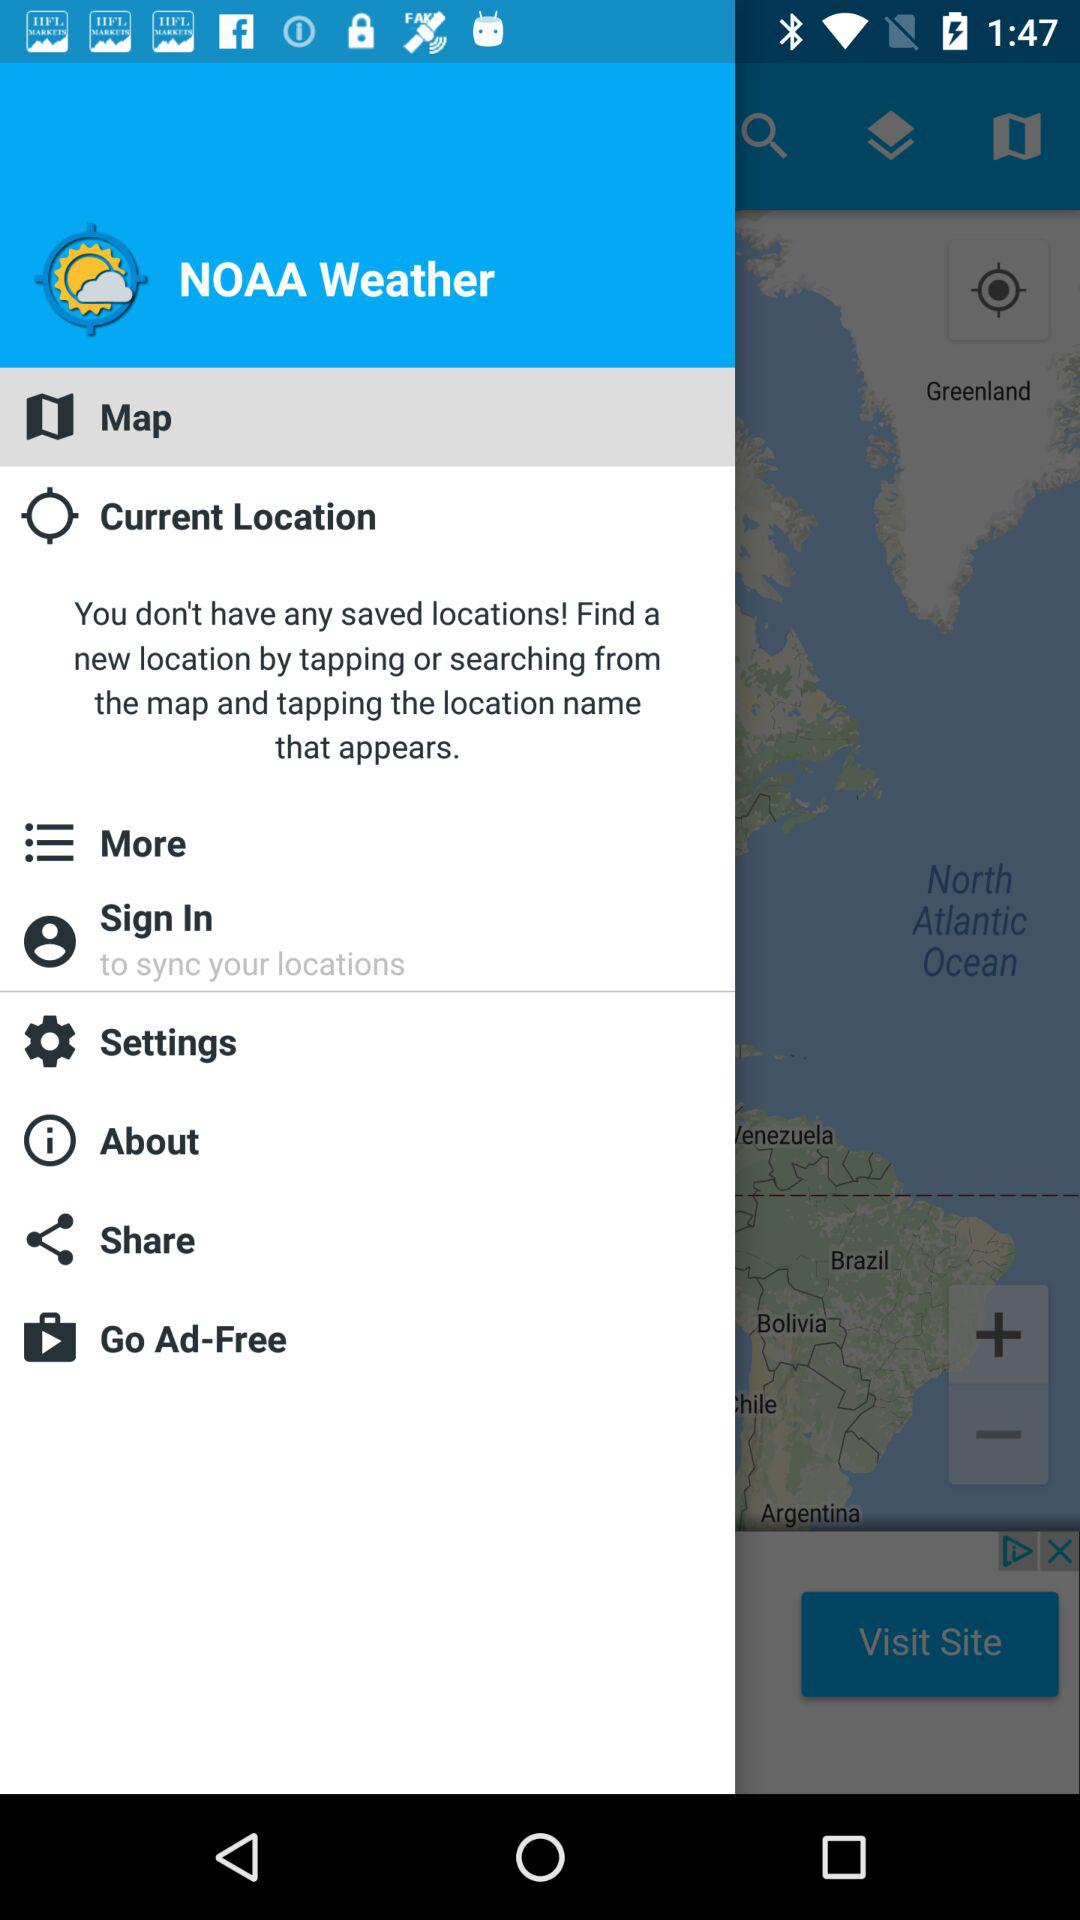What is the current location?
When the provided information is insufficient, respond with <no answer>. <no answer> 